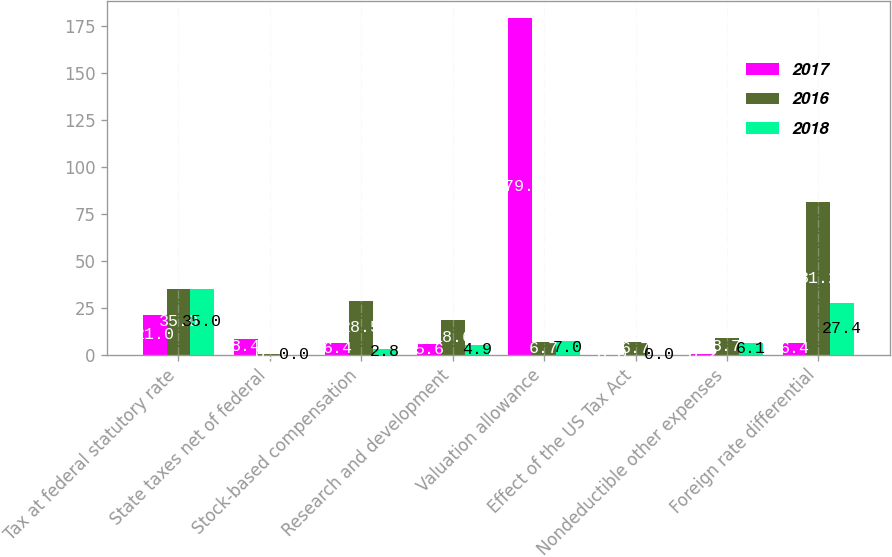Convert chart. <chart><loc_0><loc_0><loc_500><loc_500><stacked_bar_chart><ecel><fcel>Tax at federal statutory rate<fcel>State taxes net of federal<fcel>Stock-based compensation<fcel>Research and development<fcel>Valuation allowance<fcel>Effect of the US Tax Act<fcel>Nondeductible other expenses<fcel>Foreign rate differential<nl><fcel>2017<fcel>21<fcel>8.4<fcel>6.4<fcel>5.6<fcel>179.1<fcel>0<fcel>0.2<fcel>6.4<nl><fcel>2016<fcel>35<fcel>0.3<fcel>28.5<fcel>18.6<fcel>6.7<fcel>6.7<fcel>8.7<fcel>81.2<nl><fcel>2018<fcel>35<fcel>0<fcel>2.8<fcel>4.9<fcel>7<fcel>0<fcel>6.1<fcel>27.4<nl></chart> 